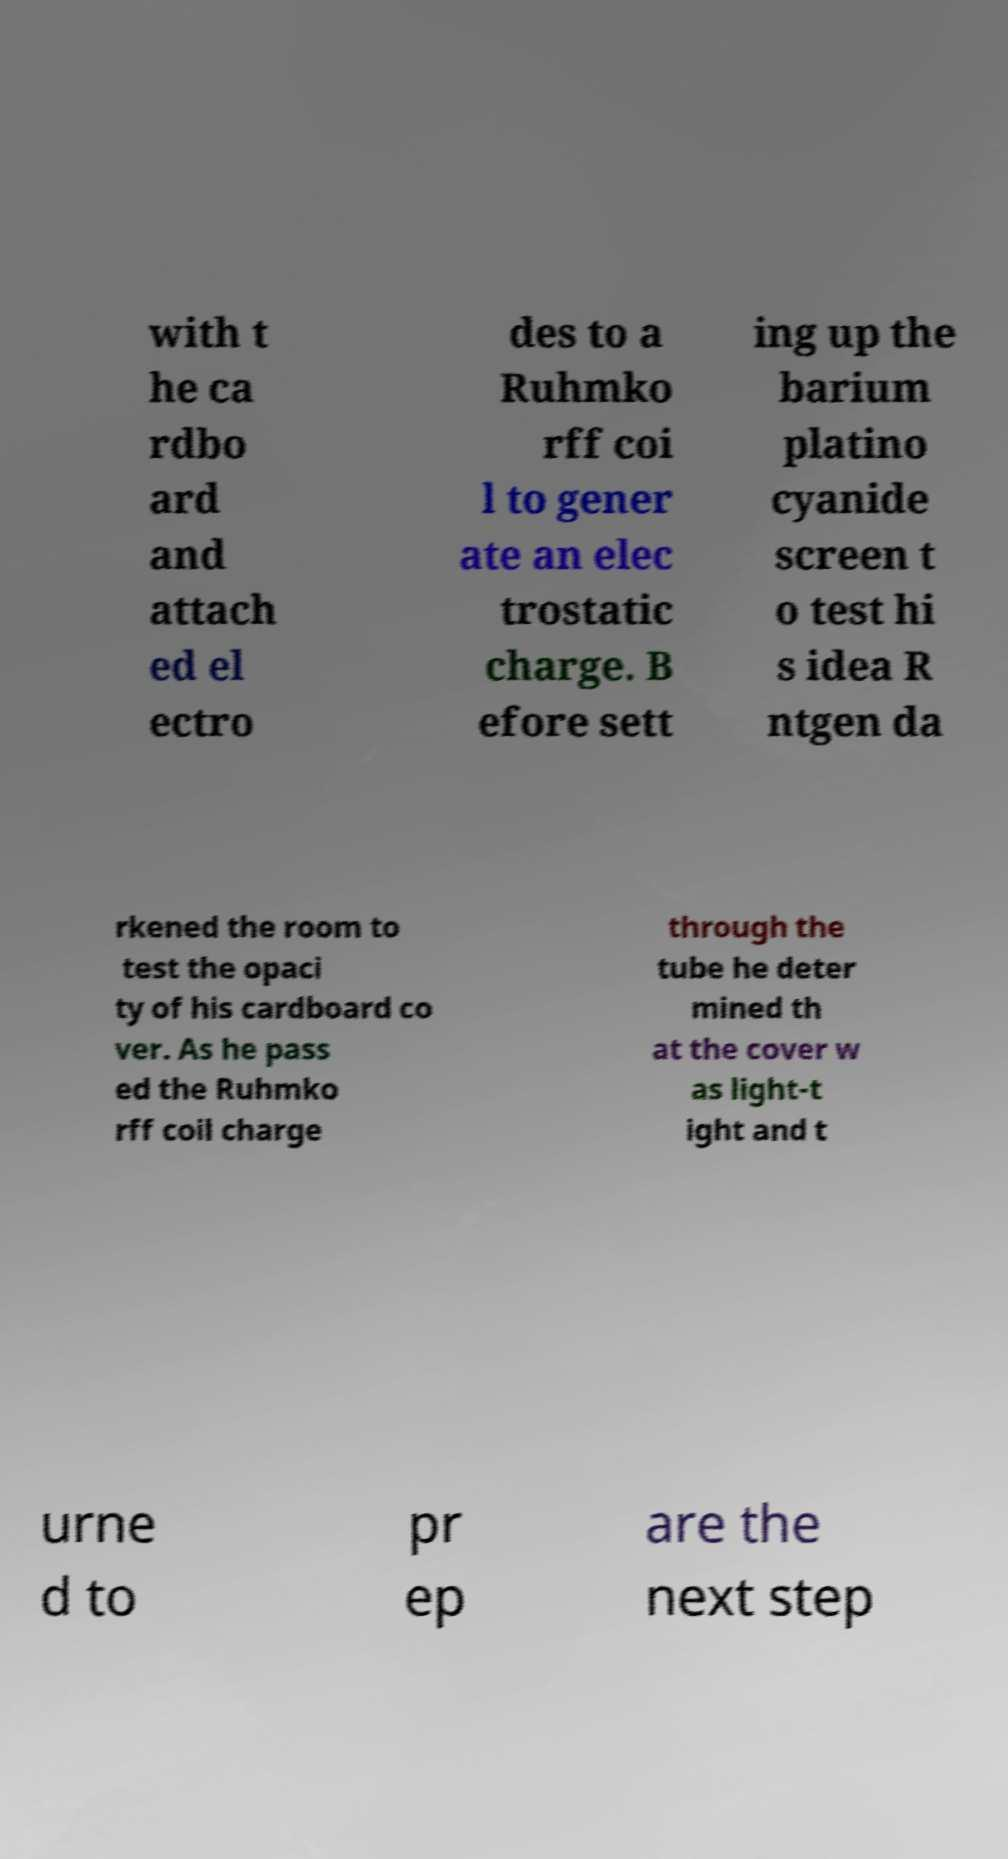I need the written content from this picture converted into text. Can you do that? with t he ca rdbo ard and attach ed el ectro des to a Ruhmko rff coi l to gener ate an elec trostatic charge. B efore sett ing up the barium platino cyanide screen t o test hi s idea R ntgen da rkened the room to test the opaci ty of his cardboard co ver. As he pass ed the Ruhmko rff coil charge through the tube he deter mined th at the cover w as light-t ight and t urne d to pr ep are the next step 